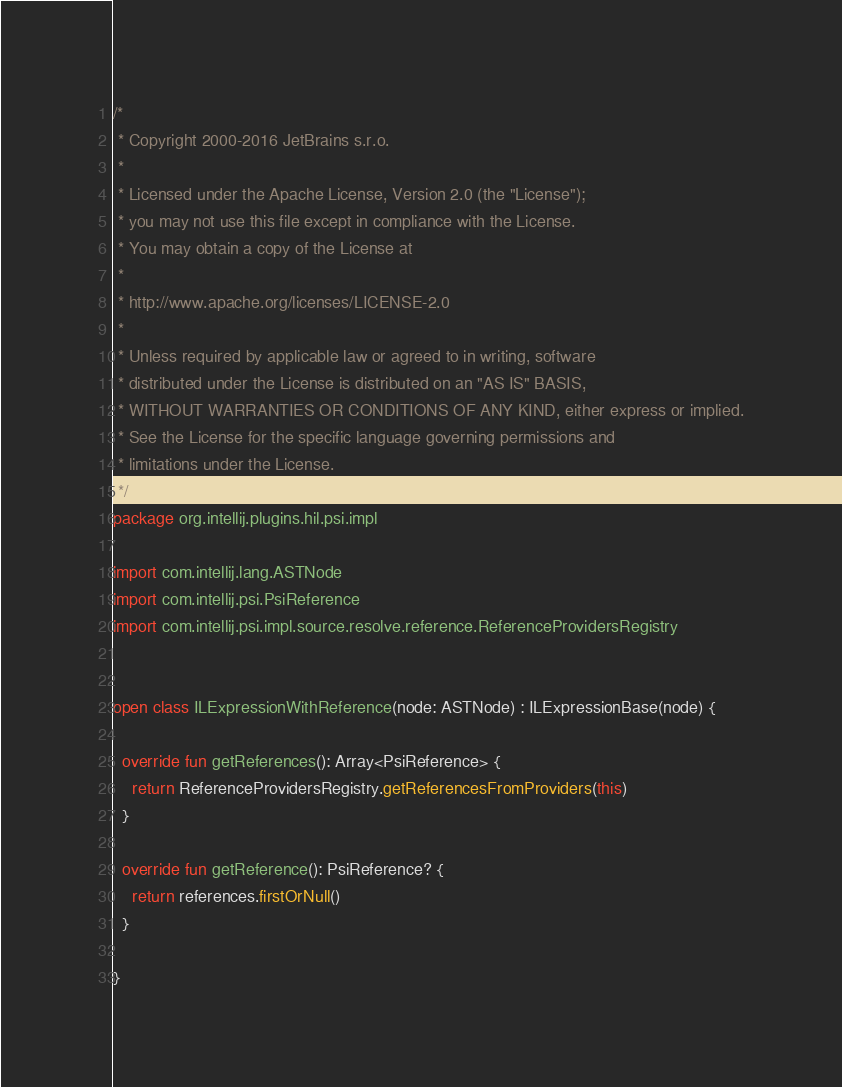Convert code to text. <code><loc_0><loc_0><loc_500><loc_500><_Kotlin_>/*
 * Copyright 2000-2016 JetBrains s.r.o.
 *
 * Licensed under the Apache License, Version 2.0 (the "License");
 * you may not use this file except in compliance with the License.
 * You may obtain a copy of the License at
 *
 * http://www.apache.org/licenses/LICENSE-2.0
 *
 * Unless required by applicable law or agreed to in writing, software
 * distributed under the License is distributed on an "AS IS" BASIS,
 * WITHOUT WARRANTIES OR CONDITIONS OF ANY KIND, either express or implied.
 * See the License for the specific language governing permissions and
 * limitations under the License.
 */
package org.intellij.plugins.hil.psi.impl

import com.intellij.lang.ASTNode
import com.intellij.psi.PsiReference
import com.intellij.psi.impl.source.resolve.reference.ReferenceProvidersRegistry


open class ILExpressionWithReference(node: ASTNode) : ILExpressionBase(node) {

  override fun getReferences(): Array<PsiReference> {
    return ReferenceProvidersRegistry.getReferencesFromProviders(this)
  }

  override fun getReference(): PsiReference? {
    return references.firstOrNull()
  }

}
</code> 